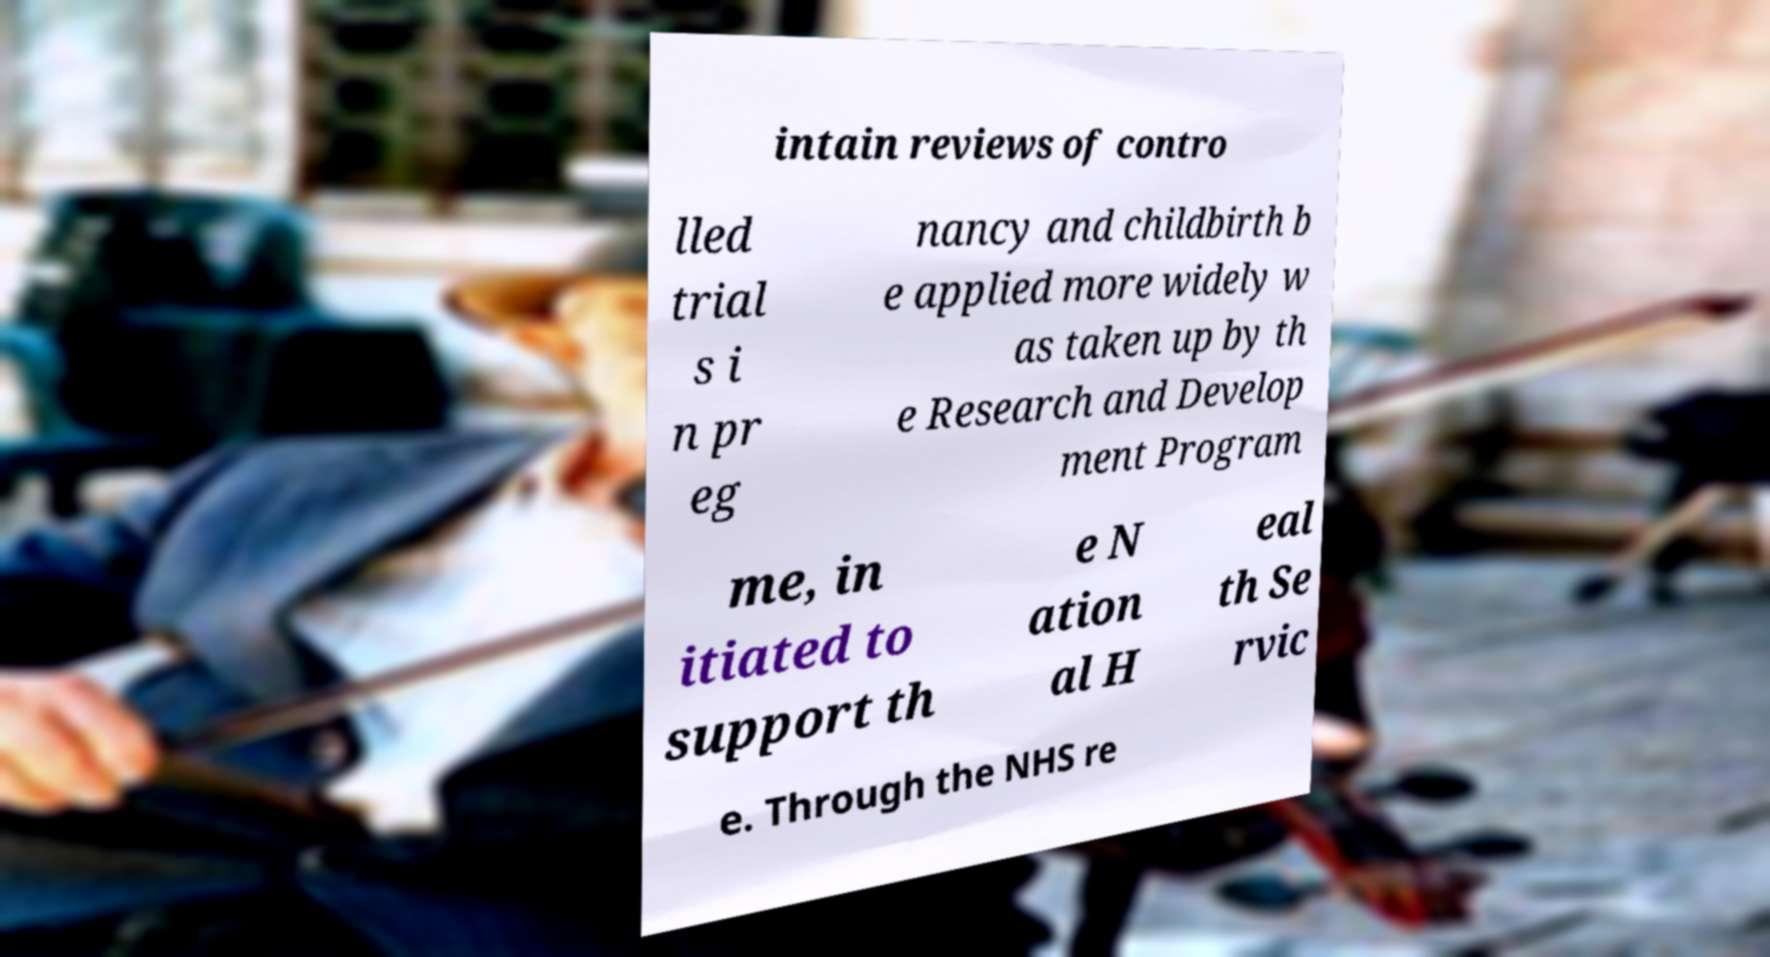Can you read and provide the text displayed in the image?This photo seems to have some interesting text. Can you extract and type it out for me? intain reviews of contro lled trial s i n pr eg nancy and childbirth b e applied more widely w as taken up by th e Research and Develop ment Program me, in itiated to support th e N ation al H eal th Se rvic e. Through the NHS re 